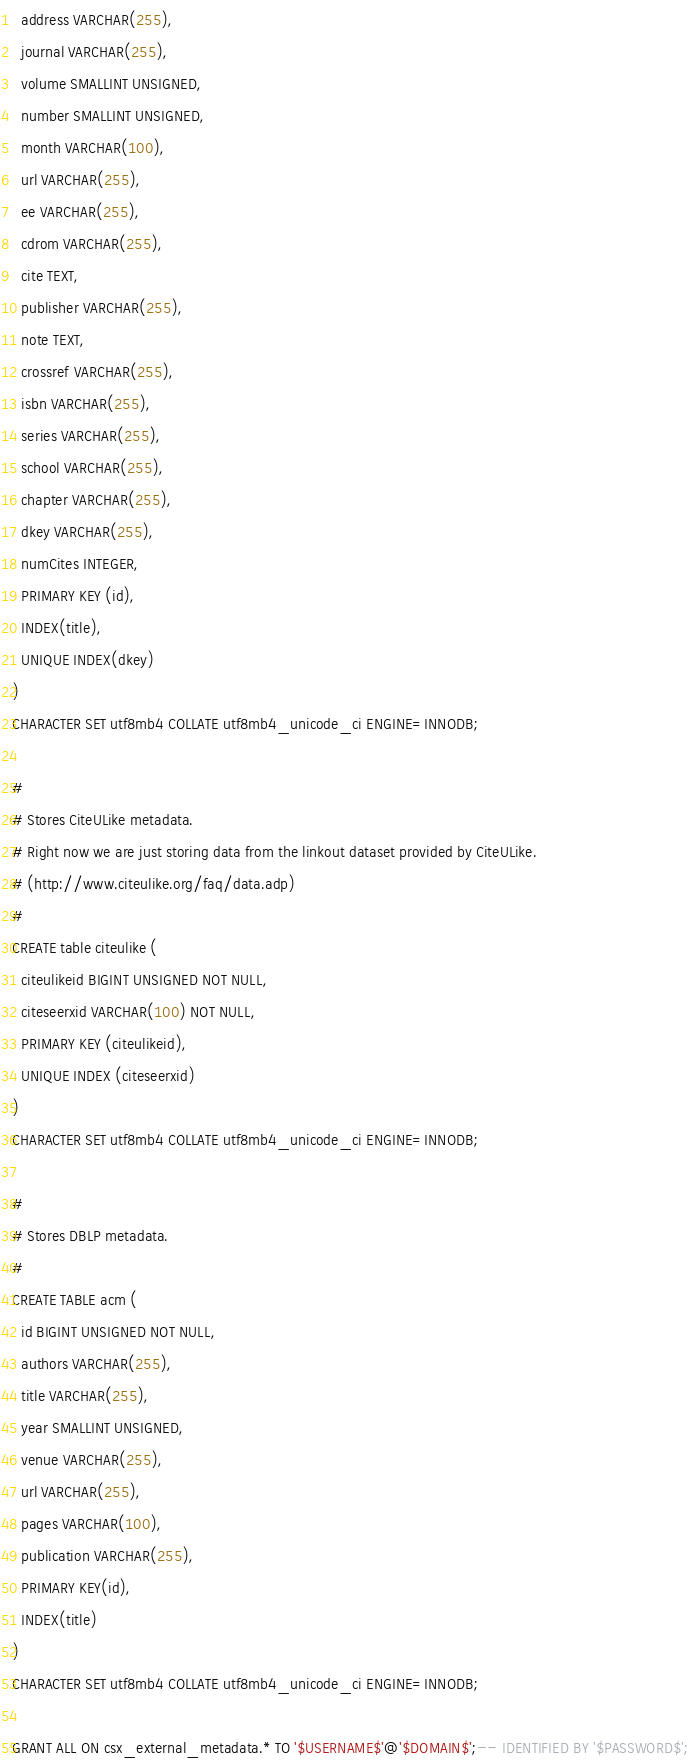Convert code to text. <code><loc_0><loc_0><loc_500><loc_500><_SQL_>  address VARCHAR(255),
  journal VARCHAR(255),
  volume SMALLINT UNSIGNED,
  number SMALLINT UNSIGNED,
  month VARCHAR(100),
  url VARCHAR(255),
  ee VARCHAR(255),
  cdrom VARCHAR(255),
  cite TEXT,
  publisher VARCHAR(255),
  note TEXT,
  crossref VARCHAR(255),
  isbn VARCHAR(255),
  series VARCHAR(255),
  school VARCHAR(255),
  chapter VARCHAR(255),
  dkey VARCHAR(255),
  numCites INTEGER,
  PRIMARY KEY (id),
  INDEX(title),
  UNIQUE INDEX(dkey)
)
CHARACTER SET utf8mb4 COLLATE utf8mb4_unicode_ci ENGINE=INNODB;

#
# Stores CiteULike metadata.
# Right now we are just storing data from the linkout dataset provided by CiteULike.
# (http://www.citeulike.org/faq/data.adp)
#
CREATE table citeulike (
  citeulikeid BIGINT UNSIGNED NOT NULL,
  citeseerxid VARCHAR(100) NOT NULL,
  PRIMARY KEY (citeulikeid),
  UNIQUE INDEX (citeseerxid)
)
CHARACTER SET utf8mb4 COLLATE utf8mb4_unicode_ci ENGINE=INNODB;

#
# Stores DBLP metadata.
#
CREATE TABLE acm (
  id BIGINT UNSIGNED NOT NULL,
  authors VARCHAR(255),
  title VARCHAR(255),
  year SMALLINT UNSIGNED,
  venue VARCHAR(255),
  url VARCHAR(255),
  pages VARCHAR(100),
  publication VARCHAR(255),
  PRIMARY KEY(id),
  INDEX(title)
)
CHARACTER SET utf8mb4 COLLATE utf8mb4_unicode_ci ENGINE=INNODB;

GRANT ALL ON csx_external_metadata.* TO '$USERNAME$'@'$DOMAIN$';-- IDENTIFIED BY '$PASSWORD$';
</code> 